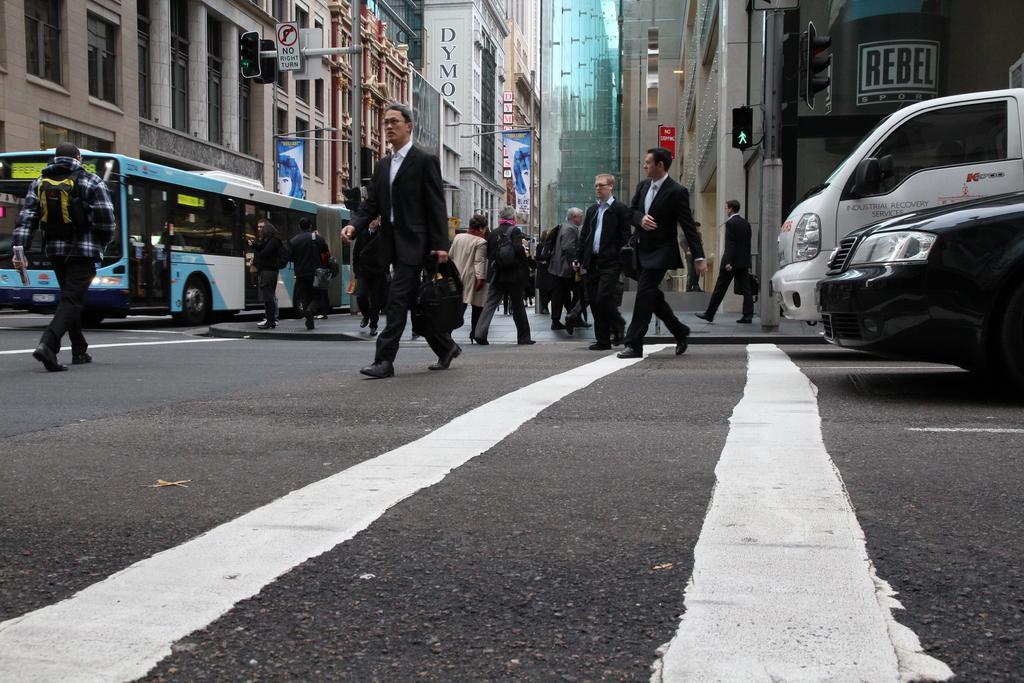In one or two sentences, can you explain what this image depicts? In this picture I can see few people walking and I can see a bus and few vehicles on the road and I can see buildings and few boards with some text. I can see few traffic signal lights to the poles. 